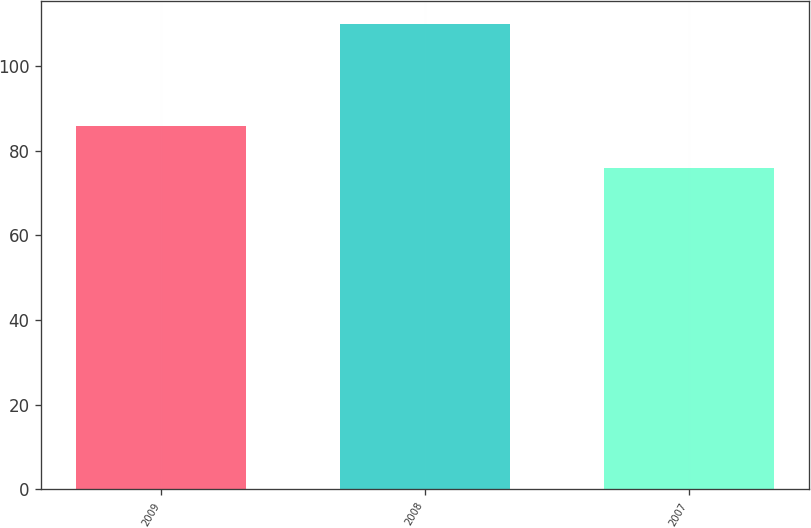Convert chart. <chart><loc_0><loc_0><loc_500><loc_500><bar_chart><fcel>2009<fcel>2008<fcel>2007<nl><fcel>86<fcel>110<fcel>76<nl></chart> 